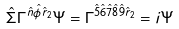Convert formula to latex. <formula><loc_0><loc_0><loc_500><loc_500>\hat { \Sigma } \Gamma ^ { \hat { n } \hat { \phi } \hat { r } _ { 2 } } \Psi = \Gamma ^ { \hat { 5 } \hat { 6 } \hat { 7 } \hat { 8 } \hat { 9 } \hat { r } _ { 2 } } = i \Psi</formula> 